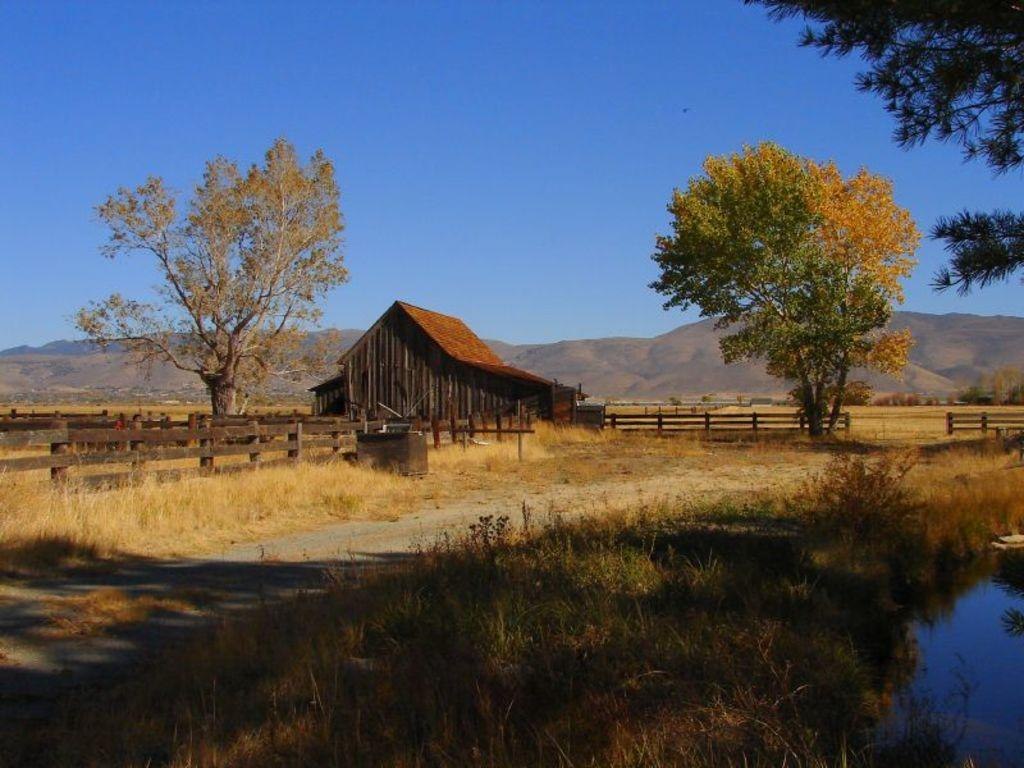What type of structure can be seen in the image? There is a shed in the image. What other natural elements are present in the image? There are trees and dry grass visible in the image. What type of barrier is present in the image? There is fencing in the image. What distant geographical feature can be seen in the image? Mountains are present in the image. What is visible in the background of the image? The sky is visible in the background of the image. How many clocks are hanging on the trees in the image? There are no clocks hanging on the trees in the image. What type of cushion is placed on the dry grass in the image? There is no cushion present on the dry grass in the image. 